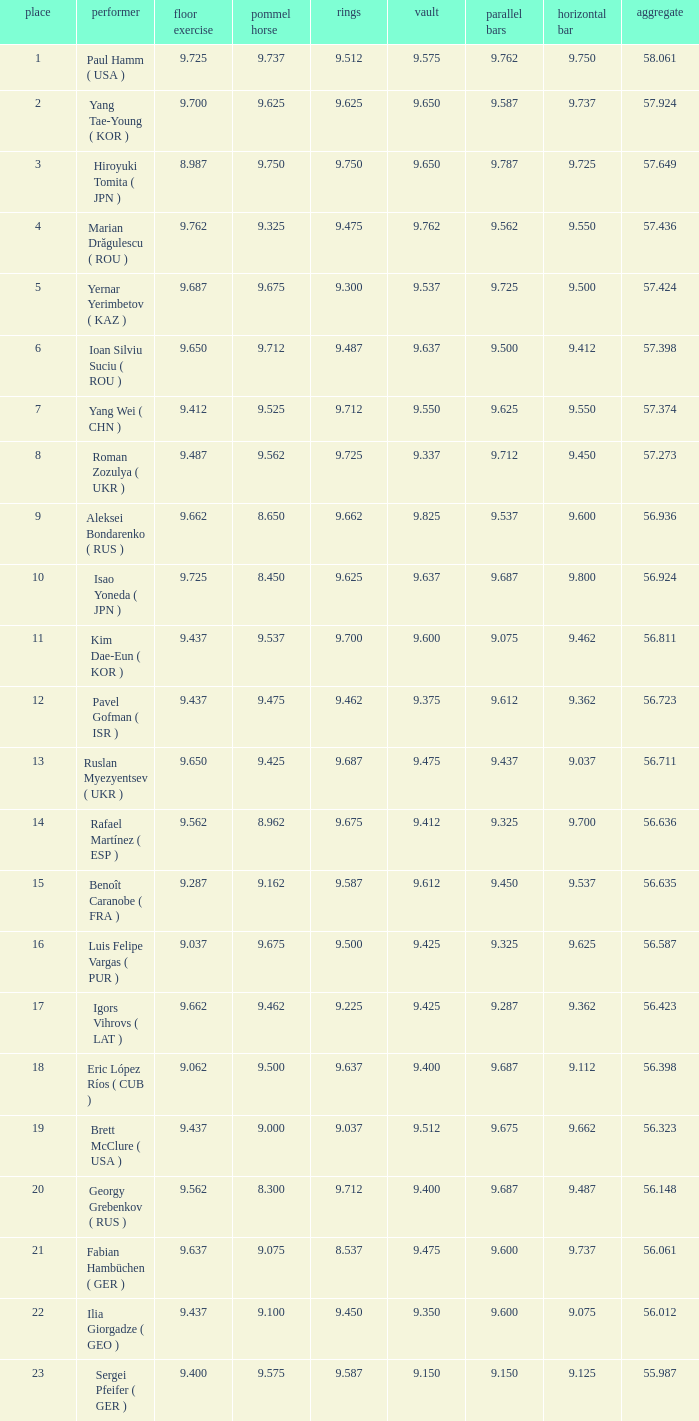What is the total score when the score for floor exercise was 9.287? 56.635. 